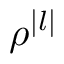Convert formula to latex. <formula><loc_0><loc_0><loc_500><loc_500>\rho ^ { | l | }</formula> 